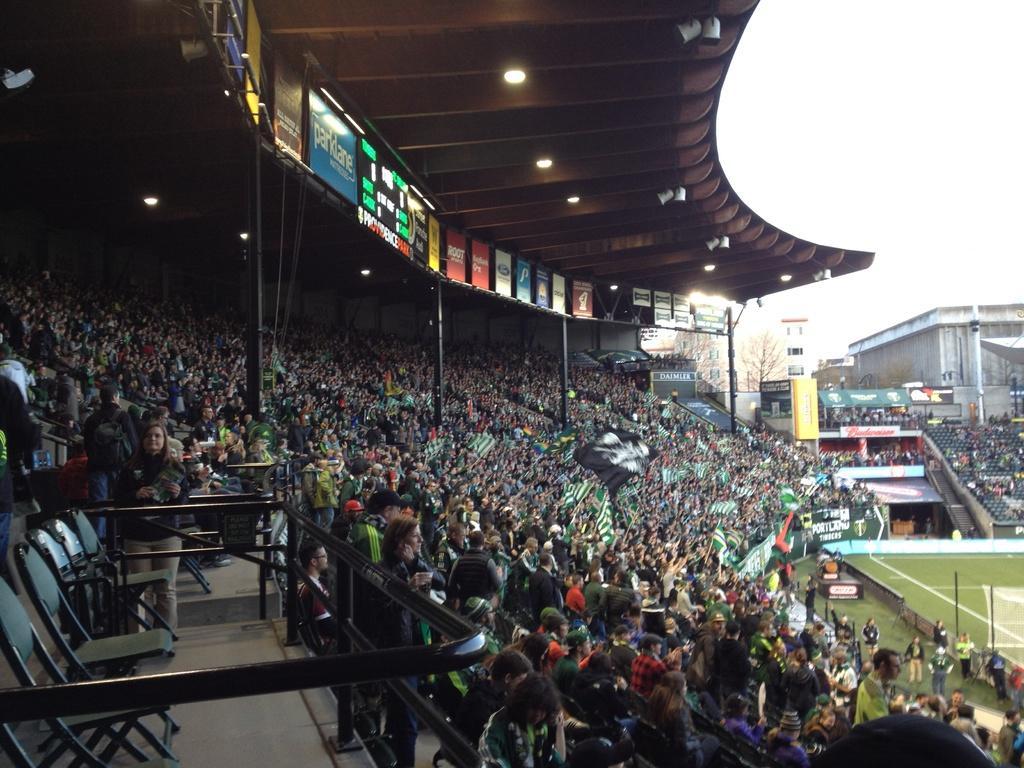Please provide a concise description of this image. In this picture we can observe a stadium. There are many people. There are men and women in this picture. On the right side there is a football ground. There are black color chairs on the left side. In the background there is a sky. 